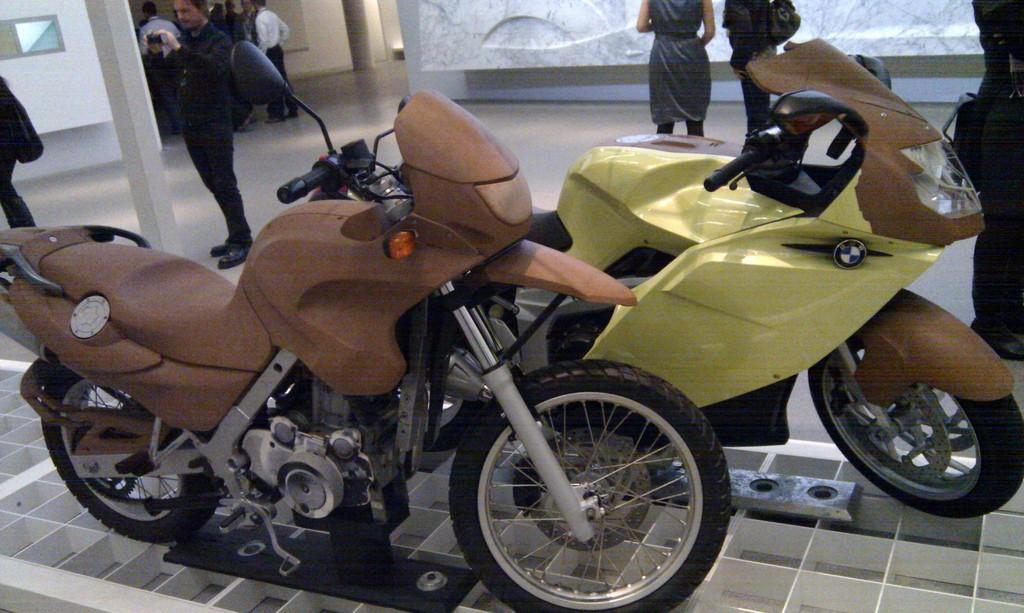How many bikes can be seen in the image? There are two bikes in the image. What are the people in the image doing? There are people standing in the image. Can you describe what one of the people is holding? One of the people is holding a camera. What architectural features are present in the image? There are two pillars in the image. What can be seen in the background of the image? There is a wall in the background of the image. What type of muscle is being exercised by the people in the image? There is no indication in the image that the people are exercising any muscles; they are simply standing. 